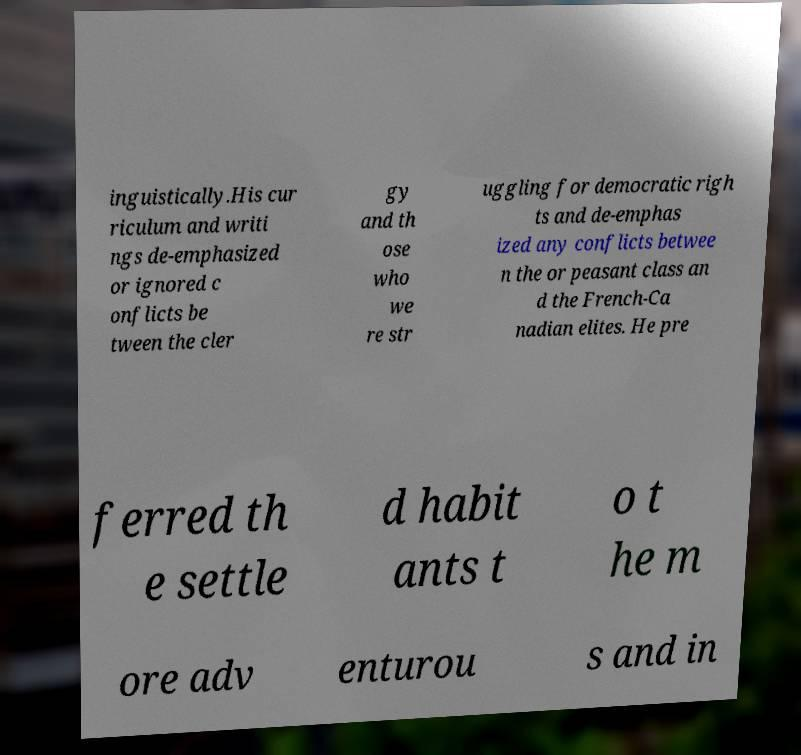Can you read and provide the text displayed in the image?This photo seems to have some interesting text. Can you extract and type it out for me? inguistically.His cur riculum and writi ngs de-emphasized or ignored c onflicts be tween the cler gy and th ose who we re str uggling for democratic righ ts and de-emphas ized any conflicts betwee n the or peasant class an d the French-Ca nadian elites. He pre ferred th e settle d habit ants t o t he m ore adv enturou s and in 